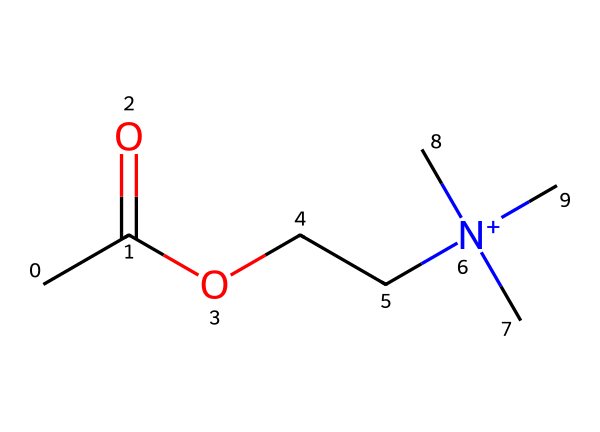What is the molecular formula of this compound? To find the molecular formula, we count the number of each type of atom in the SMILES representation. The structure indicates: 5 carbon (C) atoms, 12 hydrogen (H) atoms, 2 oxygen (O) atoms, and 1 nitrogen (N) atom. Therefore, the molecular formula is C5H12N1O2.
Answer: C5H12N1O2 How many nitrogen atoms are present in this molecule? Upon analyzing the SMILES code, there is one occurrence of the nitrogen element (N), indicating that there is one nitrogen atom in the molecule.
Answer: 1 What type of functional group is present in this structure? The structure shows a carbonyl (C=O) group attached to a hydroxyl (-OH) group, indicating that this molecule features an ester functional group. The O- linked to the carbon suggests this characteristic.
Answer: ester Which part of the molecule is responsible for its positive charge? The positive charge in the molecule is indicated by the formal positive charge on the nitrogen atom (N) where it is bonded to three carbon groups, leading to a quaternary ammonium state.
Answer: nitrogen atom What is the significance of acetylcholine in the body? Acetylcholine acts as a neurotransmitter that plays a vital role in signaling between nerve cells and is crucial for memory and cognitive function, particularly in the aging brain.
Answer: neurotransmitter What is the total number of bonds present in this molecule? By analyzing the structure, one can determine that the molecule exhibits a combination of single and double bonds. Summing these up shows a total of 9 bonds: 8 single bonds and 1 double bond.
Answer: 9 bonds 